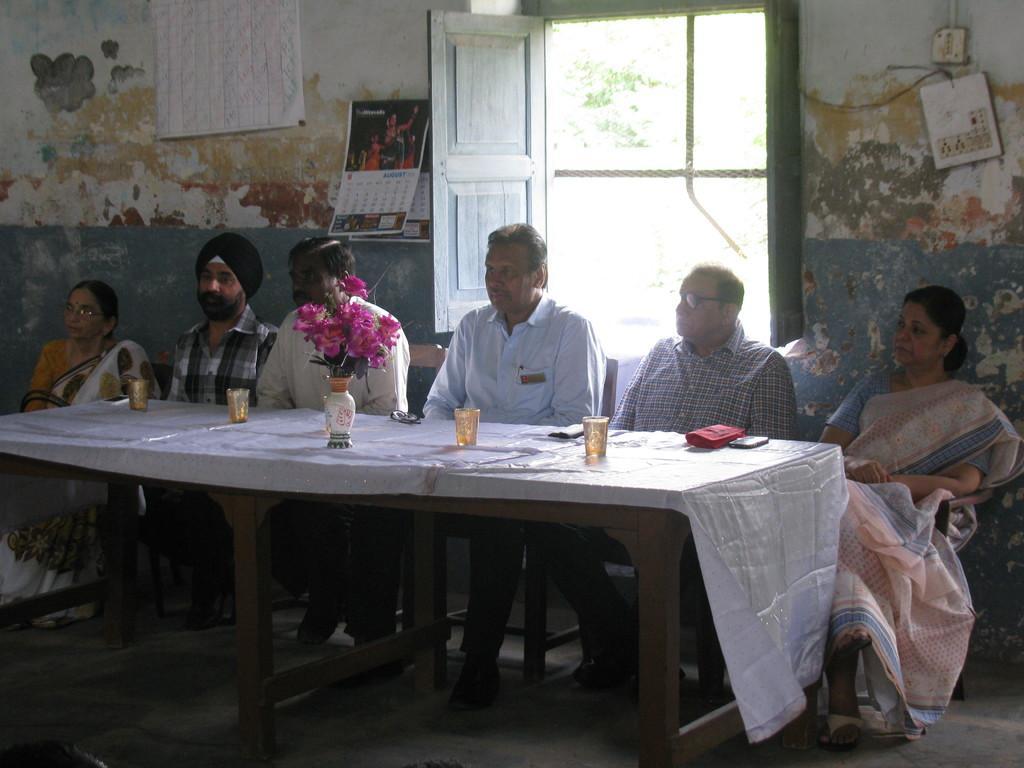Please provide a concise description of this image. In this picture there are four man in both the corners there are two ladies sitting. In the background there is a window with a rope. To the right top there is a switch board. and to the left top there is a white chart and a calendar. 